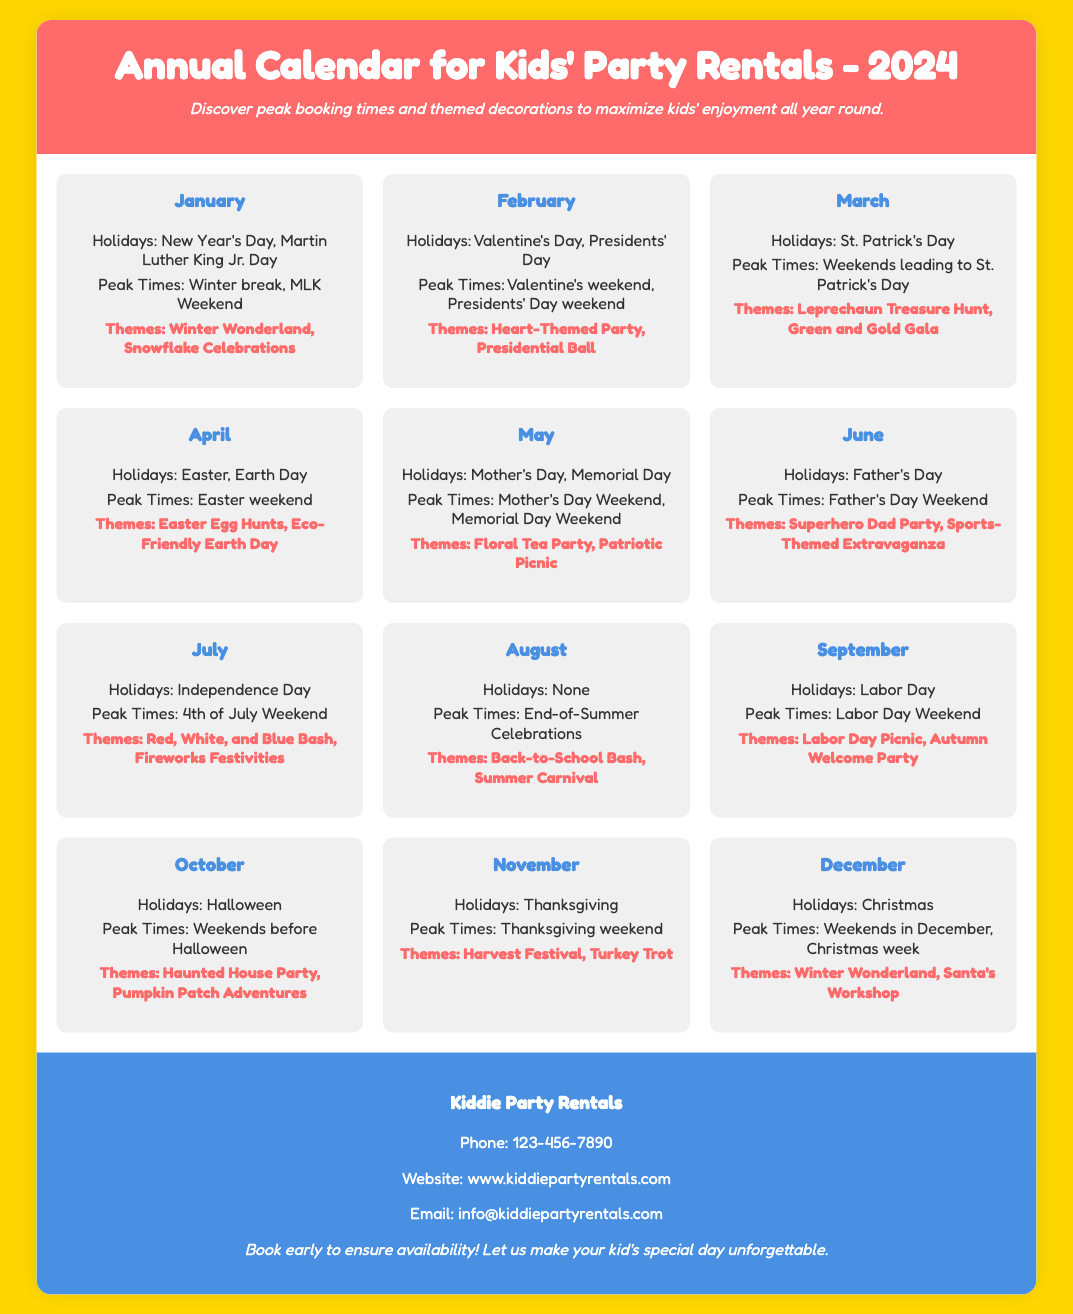What is the title of the document? The title is found at the top of the document, indicating its subject.
Answer: Annual Calendar for Kids' Party Rentals - 2024 How many holidays are listed for March? March has one holiday mentioned in the document, which can be directly counted.
Answer: 1 What is the themed decoration for October? The themes for October are specifically outlined in the document under the month section.
Answer: Haunted House Party, Pumpkin Patch Adventures During which weekend is Valentine's Day considered a peak booking time? The “Peak Times” list provides specifics on weekends associated with holidays.
Answer: Valentine's weekend What is the contact phone number for Kiddie Party Rentals? The contact information in the footer lists a phone number for inquiries.
Answer: 123-456-7890 What themes are suggested for December? The document provides a list of themes specific to December under the month heading.
Answer: Winter Wonderland, Santa's Workshop Which month has "End-of-Summer Celebrations" as a peak booking time? The specific month associated with this peak time can be found by reading through the month's details.
Answer: August How many themes are mentioned for the month of May? By looking at the themes listed in May, we can count the number of unique themes provided.
Answer: 2 What is the color of the header background? The header's background color is described in the style section indicating its visual appearance.
Answer: #FF6B6B 